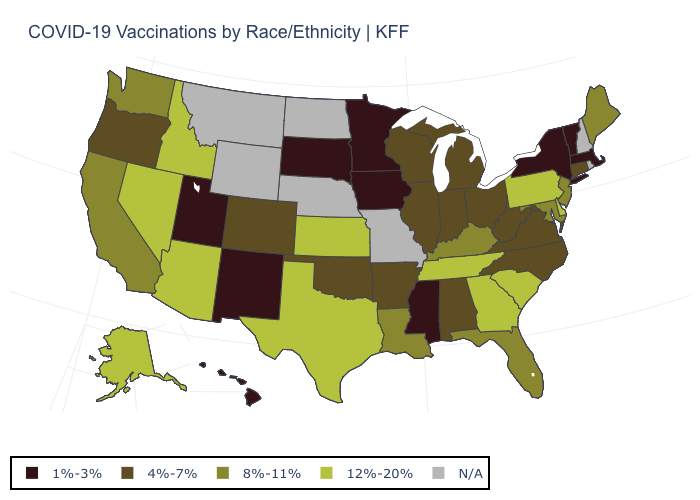Name the states that have a value in the range 1%-3%?
Be succinct. Hawaii, Iowa, Massachusetts, Minnesota, Mississippi, New Mexico, New York, South Dakota, Utah, Vermont. What is the value of Vermont?
Write a very short answer. 1%-3%. Name the states that have a value in the range 4%-7%?
Answer briefly. Alabama, Arkansas, Colorado, Connecticut, Illinois, Indiana, Michigan, North Carolina, Ohio, Oklahoma, Oregon, Virginia, West Virginia, Wisconsin. What is the lowest value in the USA?
Be succinct. 1%-3%. Which states have the highest value in the USA?
Short answer required. Alaska, Arizona, Delaware, Georgia, Idaho, Kansas, Nevada, Pennsylvania, South Carolina, Tennessee, Texas. What is the value of Connecticut?
Answer briefly. 4%-7%. Does Arizona have the highest value in the West?
Write a very short answer. Yes. What is the highest value in the USA?
Keep it brief. 12%-20%. Does Alaska have the lowest value in the USA?
Quick response, please. No. Does South Dakota have the lowest value in the MidWest?
Quick response, please. Yes. Name the states that have a value in the range 4%-7%?
Be succinct. Alabama, Arkansas, Colorado, Connecticut, Illinois, Indiana, Michigan, North Carolina, Ohio, Oklahoma, Oregon, Virginia, West Virginia, Wisconsin. 